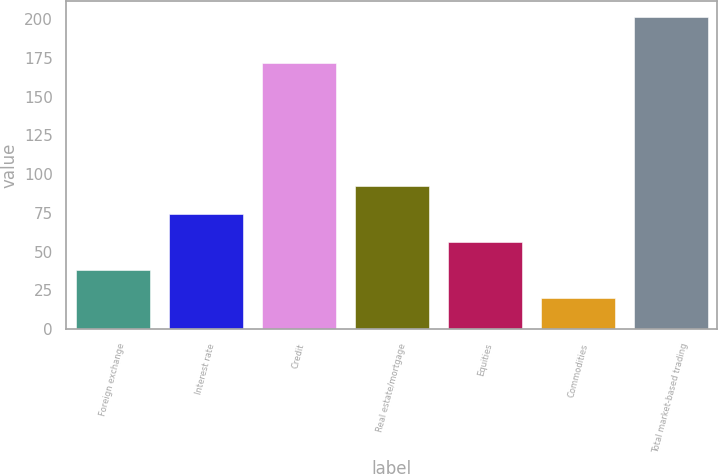Convert chart to OTSL. <chart><loc_0><loc_0><loc_500><loc_500><bar_chart><fcel>Foreign exchange<fcel>Interest rate<fcel>Credit<fcel>Real estate/mortgage<fcel>Equities<fcel>Commodities<fcel>Total market-based trading<nl><fcel>38.04<fcel>74.32<fcel>171.5<fcel>92.46<fcel>56.18<fcel>19.9<fcel>201.3<nl></chart> 